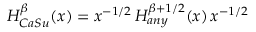<formula> <loc_0><loc_0><loc_500><loc_500>H _ { C a S u } ^ { \beta } ( x ) = x ^ { - 1 / 2 } \, H _ { a n y } ^ { \beta + 1 / 2 } ( x ) \, x ^ { - 1 / 2 }</formula> 